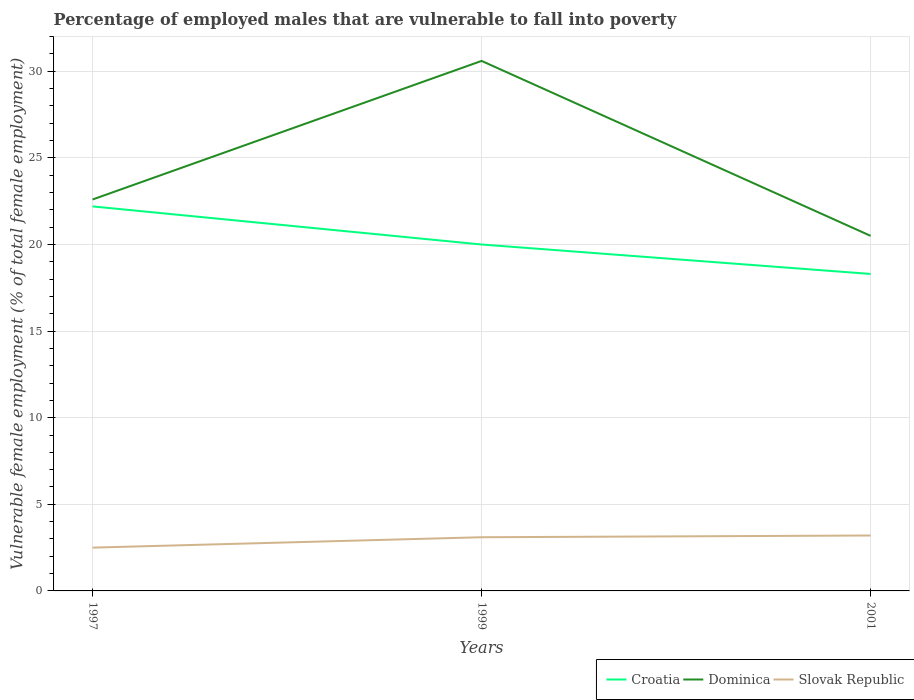How many different coloured lines are there?
Provide a succinct answer. 3. Does the line corresponding to Croatia intersect with the line corresponding to Slovak Republic?
Offer a terse response. No. Across all years, what is the maximum percentage of employed males who are vulnerable to fall into poverty in Croatia?
Offer a very short reply. 18.3. In which year was the percentage of employed males who are vulnerable to fall into poverty in Croatia maximum?
Offer a terse response. 2001. What is the difference between the highest and the second highest percentage of employed males who are vulnerable to fall into poverty in Slovak Republic?
Provide a succinct answer. 0.7. What is the difference between the highest and the lowest percentage of employed males who are vulnerable to fall into poverty in Croatia?
Keep it short and to the point. 1. Is the percentage of employed males who are vulnerable to fall into poverty in Slovak Republic strictly greater than the percentage of employed males who are vulnerable to fall into poverty in Dominica over the years?
Your answer should be very brief. Yes. How many years are there in the graph?
Provide a short and direct response. 3. What is the difference between two consecutive major ticks on the Y-axis?
Your answer should be very brief. 5. Are the values on the major ticks of Y-axis written in scientific E-notation?
Ensure brevity in your answer.  No. What is the title of the graph?
Provide a short and direct response. Percentage of employed males that are vulnerable to fall into poverty. Does "Pacific island small states" appear as one of the legend labels in the graph?
Your response must be concise. No. What is the label or title of the Y-axis?
Ensure brevity in your answer.  Vulnerable female employment (% of total female employment). What is the Vulnerable female employment (% of total female employment) in Croatia in 1997?
Your answer should be very brief. 22.2. What is the Vulnerable female employment (% of total female employment) of Dominica in 1997?
Keep it short and to the point. 22.6. What is the Vulnerable female employment (% of total female employment) of Slovak Republic in 1997?
Offer a very short reply. 2.5. What is the Vulnerable female employment (% of total female employment) in Croatia in 1999?
Make the answer very short. 20. What is the Vulnerable female employment (% of total female employment) of Dominica in 1999?
Your response must be concise. 30.6. What is the Vulnerable female employment (% of total female employment) in Slovak Republic in 1999?
Offer a very short reply. 3.1. What is the Vulnerable female employment (% of total female employment) in Croatia in 2001?
Make the answer very short. 18.3. What is the Vulnerable female employment (% of total female employment) of Dominica in 2001?
Your response must be concise. 20.5. What is the Vulnerable female employment (% of total female employment) of Slovak Republic in 2001?
Offer a terse response. 3.2. Across all years, what is the maximum Vulnerable female employment (% of total female employment) of Croatia?
Keep it short and to the point. 22.2. Across all years, what is the maximum Vulnerable female employment (% of total female employment) in Dominica?
Your answer should be very brief. 30.6. Across all years, what is the maximum Vulnerable female employment (% of total female employment) in Slovak Republic?
Your answer should be compact. 3.2. Across all years, what is the minimum Vulnerable female employment (% of total female employment) in Croatia?
Make the answer very short. 18.3. Across all years, what is the minimum Vulnerable female employment (% of total female employment) of Dominica?
Your response must be concise. 20.5. What is the total Vulnerable female employment (% of total female employment) in Croatia in the graph?
Give a very brief answer. 60.5. What is the total Vulnerable female employment (% of total female employment) of Dominica in the graph?
Keep it short and to the point. 73.7. What is the difference between the Vulnerable female employment (% of total female employment) of Croatia in 1997 and that in 1999?
Give a very brief answer. 2.2. What is the difference between the Vulnerable female employment (% of total female employment) in Dominica in 1997 and that in 1999?
Offer a terse response. -8. What is the difference between the Vulnerable female employment (% of total female employment) in Dominica in 1997 and that in 2001?
Offer a terse response. 2.1. What is the difference between the Vulnerable female employment (% of total female employment) of Slovak Republic in 1997 and that in 2001?
Offer a terse response. -0.7. What is the difference between the Vulnerable female employment (% of total female employment) of Dominica in 1999 and that in 2001?
Offer a terse response. 10.1. What is the difference between the Vulnerable female employment (% of total female employment) of Dominica in 1997 and the Vulnerable female employment (% of total female employment) of Slovak Republic in 1999?
Offer a terse response. 19.5. What is the difference between the Vulnerable female employment (% of total female employment) in Dominica in 1997 and the Vulnerable female employment (% of total female employment) in Slovak Republic in 2001?
Keep it short and to the point. 19.4. What is the difference between the Vulnerable female employment (% of total female employment) in Dominica in 1999 and the Vulnerable female employment (% of total female employment) in Slovak Republic in 2001?
Your response must be concise. 27.4. What is the average Vulnerable female employment (% of total female employment) of Croatia per year?
Your answer should be compact. 20.17. What is the average Vulnerable female employment (% of total female employment) in Dominica per year?
Your response must be concise. 24.57. What is the average Vulnerable female employment (% of total female employment) of Slovak Republic per year?
Make the answer very short. 2.93. In the year 1997, what is the difference between the Vulnerable female employment (% of total female employment) of Croatia and Vulnerable female employment (% of total female employment) of Dominica?
Provide a succinct answer. -0.4. In the year 1997, what is the difference between the Vulnerable female employment (% of total female employment) in Dominica and Vulnerable female employment (% of total female employment) in Slovak Republic?
Your answer should be very brief. 20.1. In the year 1999, what is the difference between the Vulnerable female employment (% of total female employment) of Croatia and Vulnerable female employment (% of total female employment) of Slovak Republic?
Offer a terse response. 16.9. In the year 2001, what is the difference between the Vulnerable female employment (% of total female employment) of Croatia and Vulnerable female employment (% of total female employment) of Slovak Republic?
Give a very brief answer. 15.1. In the year 2001, what is the difference between the Vulnerable female employment (% of total female employment) in Dominica and Vulnerable female employment (% of total female employment) in Slovak Republic?
Your response must be concise. 17.3. What is the ratio of the Vulnerable female employment (% of total female employment) in Croatia in 1997 to that in 1999?
Your answer should be very brief. 1.11. What is the ratio of the Vulnerable female employment (% of total female employment) of Dominica in 1997 to that in 1999?
Ensure brevity in your answer.  0.74. What is the ratio of the Vulnerable female employment (% of total female employment) in Slovak Republic in 1997 to that in 1999?
Make the answer very short. 0.81. What is the ratio of the Vulnerable female employment (% of total female employment) in Croatia in 1997 to that in 2001?
Your answer should be compact. 1.21. What is the ratio of the Vulnerable female employment (% of total female employment) of Dominica in 1997 to that in 2001?
Ensure brevity in your answer.  1.1. What is the ratio of the Vulnerable female employment (% of total female employment) of Slovak Republic in 1997 to that in 2001?
Make the answer very short. 0.78. What is the ratio of the Vulnerable female employment (% of total female employment) of Croatia in 1999 to that in 2001?
Offer a very short reply. 1.09. What is the ratio of the Vulnerable female employment (% of total female employment) in Dominica in 1999 to that in 2001?
Provide a succinct answer. 1.49. What is the ratio of the Vulnerable female employment (% of total female employment) of Slovak Republic in 1999 to that in 2001?
Offer a terse response. 0.97. What is the difference between the highest and the lowest Vulnerable female employment (% of total female employment) of Dominica?
Make the answer very short. 10.1. What is the difference between the highest and the lowest Vulnerable female employment (% of total female employment) of Slovak Republic?
Make the answer very short. 0.7. 